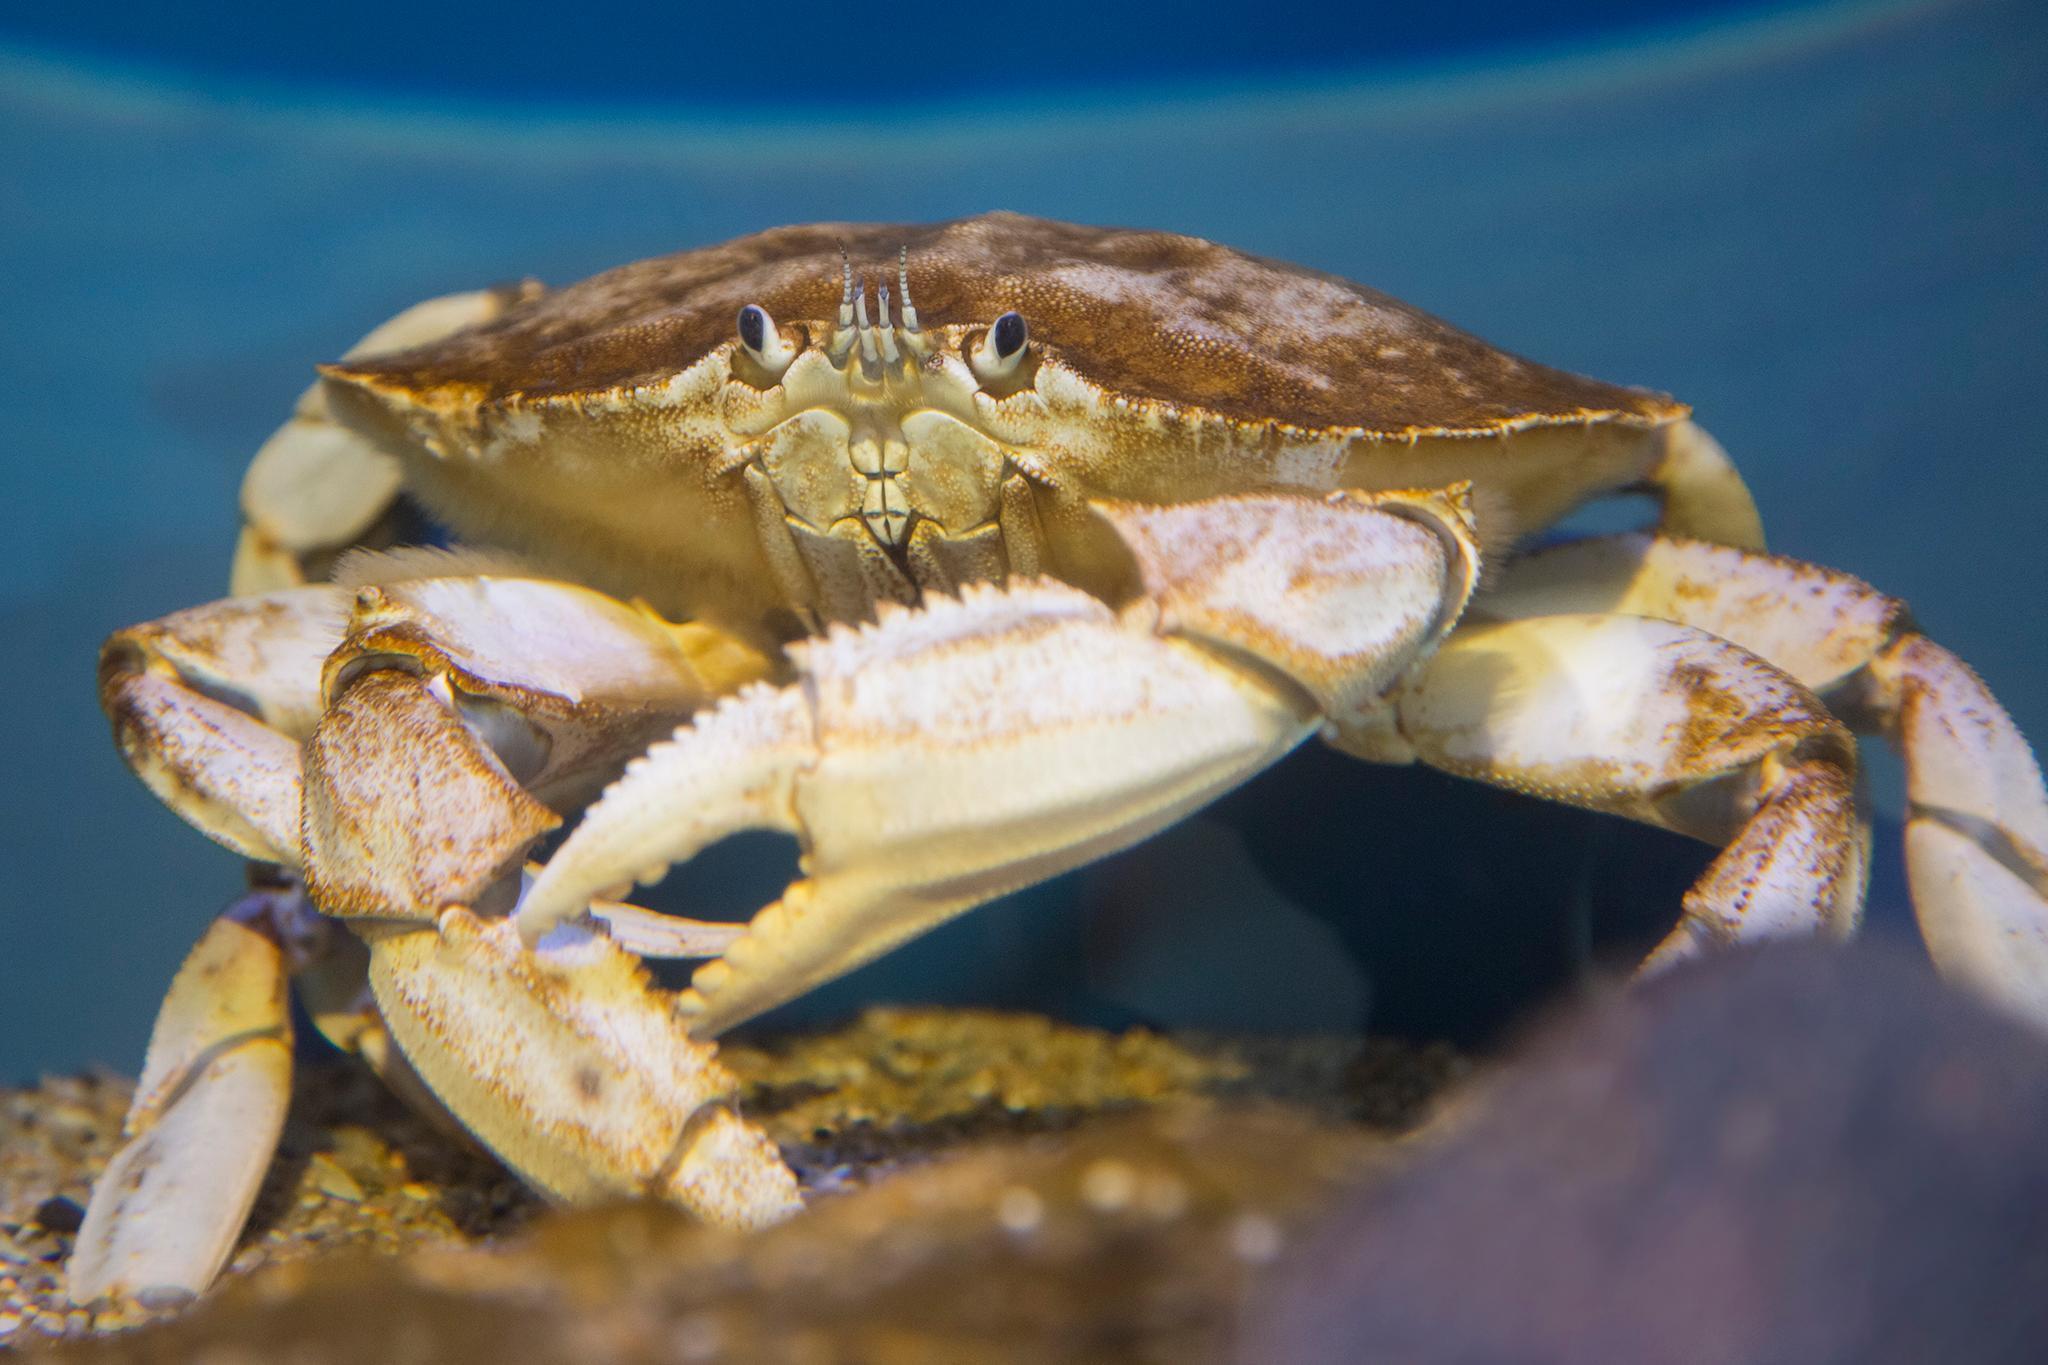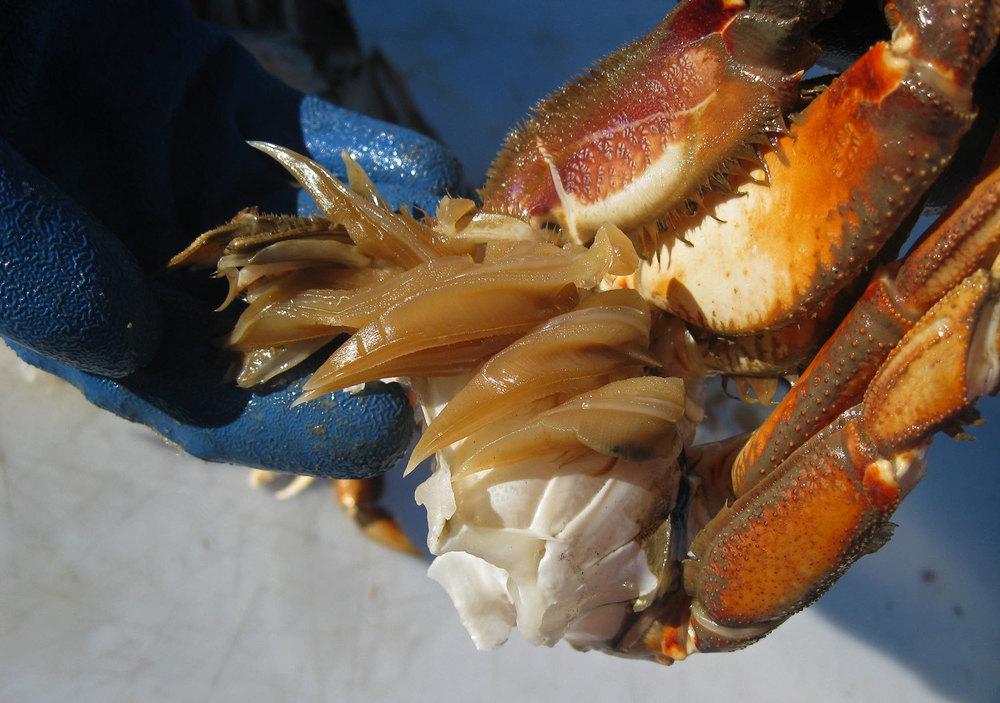The first image is the image on the left, the second image is the image on the right. For the images displayed, is the sentence "Each image includes a forward-facing crab, and in one image, a crab is held by a bare hand." factually correct? Answer yes or no. No. The first image is the image on the left, the second image is the image on the right. Evaluate the accuracy of this statement regarding the images: "In at least one image there is an ungloved hand holding a live crab.". Is it true? Answer yes or no. No. 